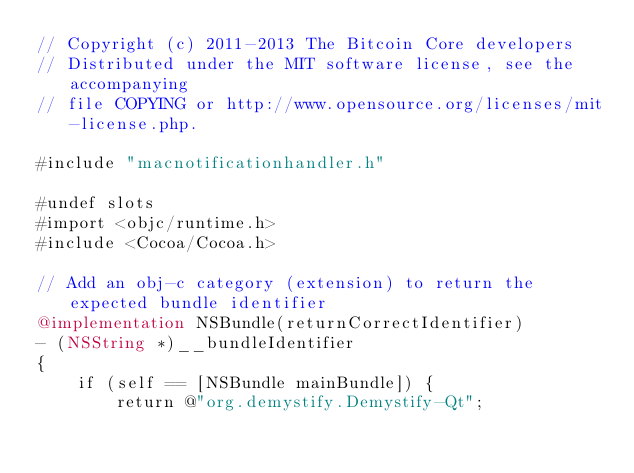Convert code to text. <code><loc_0><loc_0><loc_500><loc_500><_ObjectiveC_>// Copyright (c) 2011-2013 The Bitcoin Core developers
// Distributed under the MIT software license, see the accompanying
// file COPYING or http://www.opensource.org/licenses/mit-license.php.

#include "macnotificationhandler.h"

#undef slots
#import <objc/runtime.h>
#include <Cocoa/Cocoa.h>

// Add an obj-c category (extension) to return the expected bundle identifier
@implementation NSBundle(returnCorrectIdentifier)
- (NSString *)__bundleIdentifier
{
    if (self == [NSBundle mainBundle]) {
        return @"org.demystify.Demystify-Qt";</code> 